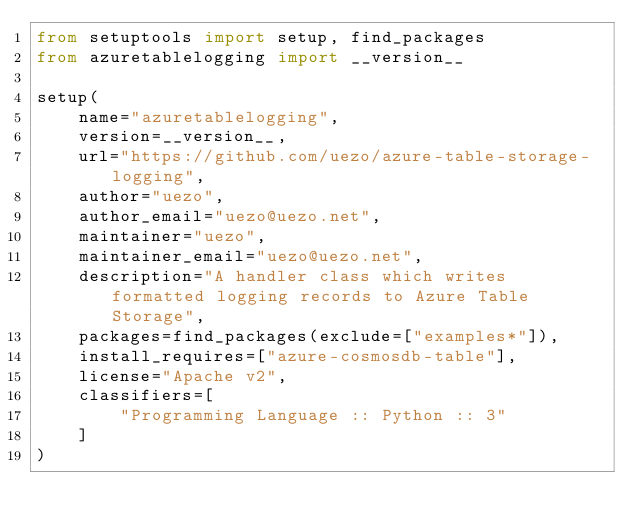<code> <loc_0><loc_0><loc_500><loc_500><_Python_>from setuptools import setup, find_packages
from azuretablelogging import __version__

setup(
    name="azuretablelogging",
    version=__version__,
    url="https://github.com/uezo/azure-table-storage-logging",
    author="uezo",
    author_email="uezo@uezo.net",
    maintainer="uezo",
    maintainer_email="uezo@uezo.net",
    description="A handler class which writes formatted logging records to Azure Table Storage",
    packages=find_packages(exclude=["examples*"]),
    install_requires=["azure-cosmosdb-table"],
    license="Apache v2",
    classifiers=[
        "Programming Language :: Python :: 3"
    ]
)
</code> 